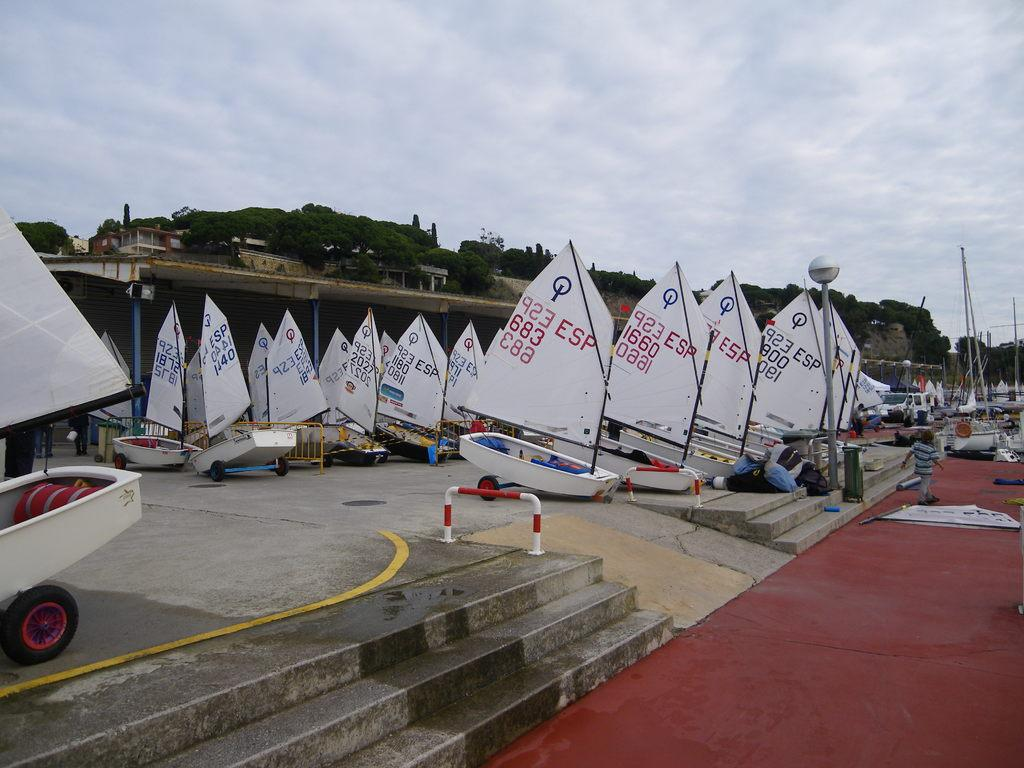What objects are on the floor in the image? There are boats on the floor in the image. What other objects can be seen in the image? There are poles, steps, and rods in the image. What is visible in the background of the image? There are trees in the background of the image. What is visible at the top of the image? The sky is visible at the top of the image. Where is the mark located in the image? There is no mark present in the image. What type of food is being served in the lunchroom in the image? There is no lunchroom present in the image. 